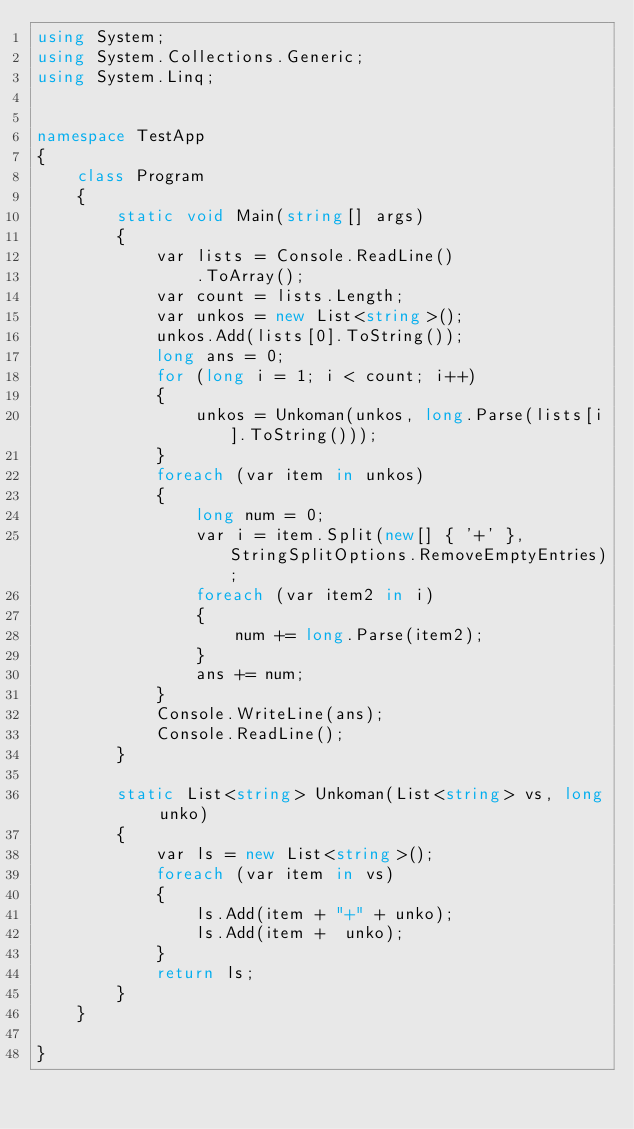<code> <loc_0><loc_0><loc_500><loc_500><_C#_>using System;
using System.Collections.Generic;
using System.Linq;


namespace TestApp
{
    class Program
    {
        static void Main(string[] args)
        {
            var lists = Console.ReadLine()
                .ToArray();
            var count = lists.Length;
            var unkos = new List<string>();
            unkos.Add(lists[0].ToString());
            long ans = 0;
            for (long i = 1; i < count; i++)
            {
                unkos = Unkoman(unkos, long.Parse(lists[i].ToString()));
            }
            foreach (var item in unkos)
            {
                long num = 0;
                var i = item.Split(new[] { '+' }, StringSplitOptions.RemoveEmptyEntries);
                foreach (var item2 in i)
                {
                    num += long.Parse(item2);
                }
                ans += num;
            }
            Console.WriteLine(ans);
            Console.ReadLine();
        }

        static List<string> Unkoman(List<string> vs, long unko)
        {
            var ls = new List<string>();
            foreach (var item in vs)
            {
                ls.Add(item + "+" + unko);
                ls.Add(item +  unko);
            }
            return ls;
        }
    }
    
}
</code> 